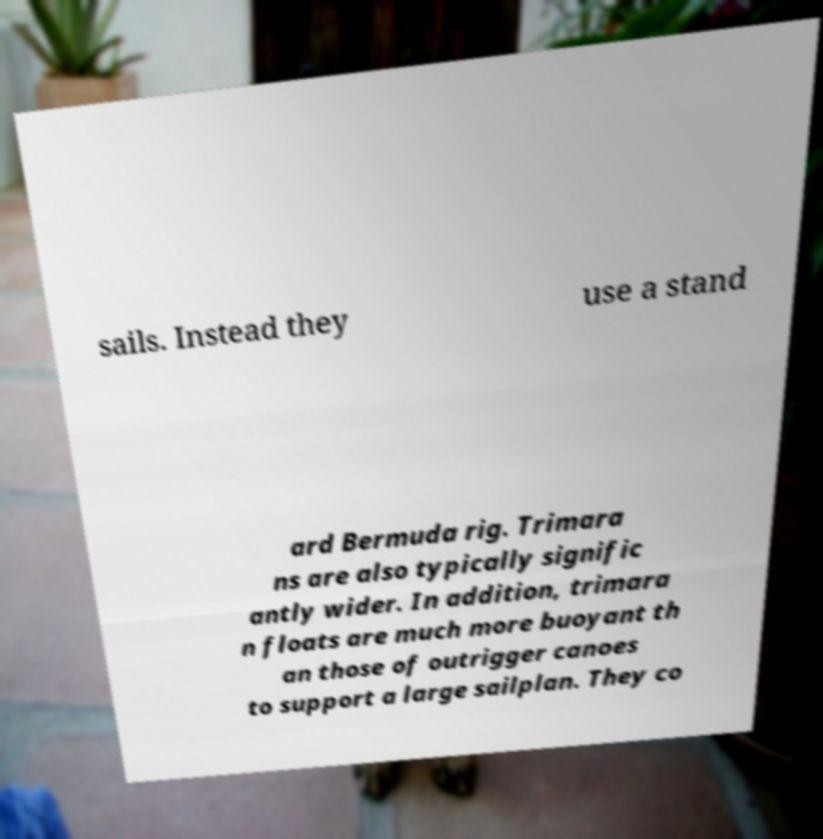Can you accurately transcribe the text from the provided image for me? sails. Instead they use a stand ard Bermuda rig. Trimara ns are also typically signific antly wider. In addition, trimara n floats are much more buoyant th an those of outrigger canoes to support a large sailplan. They co 